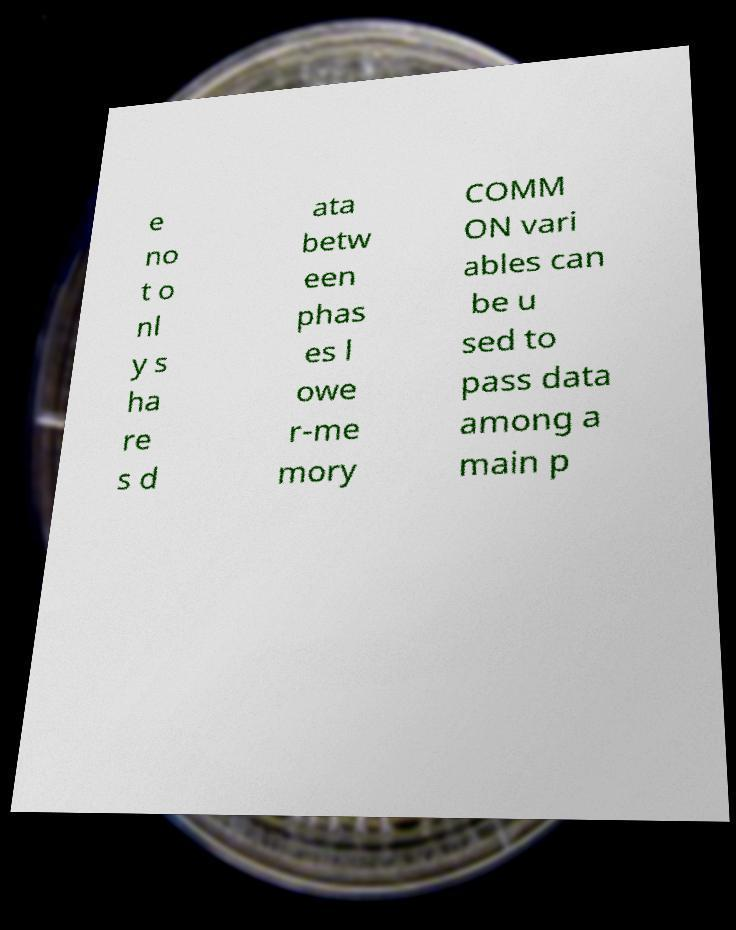I need the written content from this picture converted into text. Can you do that? e no t o nl y s ha re s d ata betw een phas es l owe r-me mory COMM ON vari ables can be u sed to pass data among a main p 